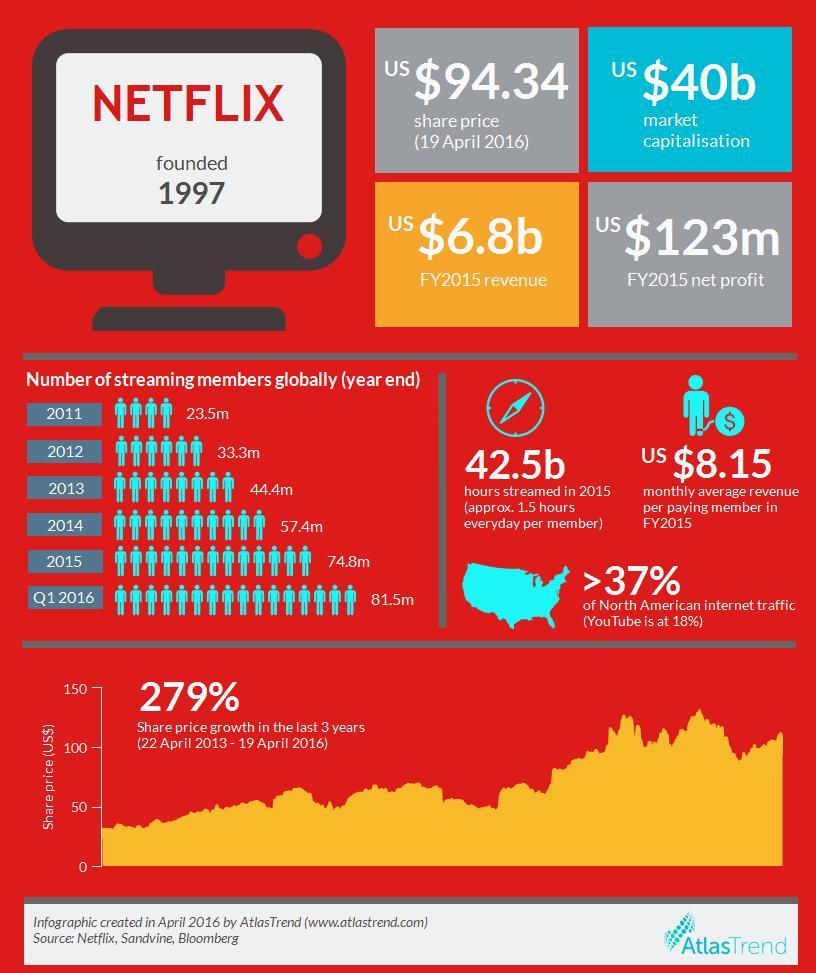What is the share price (in US dollars) of Netflix as of 19 April 2016?
Answer the question with a short phrase. 94.34 What is the net profit (in US dollars) of Netflix in the fiscal year 2015? 123m What is Netflix's monthly average revenue (in US dollars) per paying member in the fiscal year 2015? 8.15 What is Netflix's revenue (in US dollars) in the fiscal year 2015? 6.8b What is the number of streaming members of Netflix globally in the year-end of 2014? 57.4m 